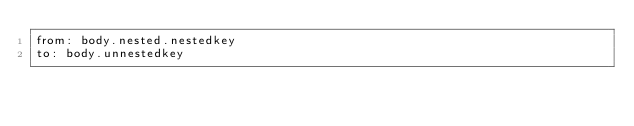Convert code to text. <code><loc_0><loc_0><loc_500><loc_500><_YAML_>from: body.nested.nestedkey
to: body.unnestedkey
</code> 